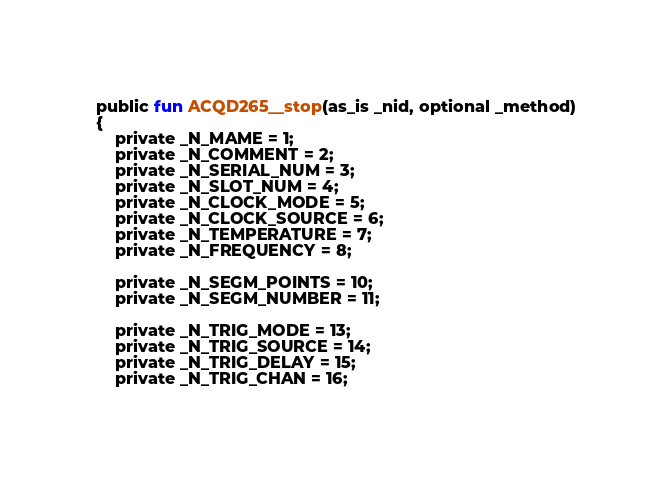Convert code to text. <code><loc_0><loc_0><loc_500><loc_500><_SML_>public fun ACQD265__stop(as_is _nid, optional _method)
{
    private _N_MAME = 1;
    private _N_COMMENT = 2;
    private _N_SERIAL_NUM = 3;
    private _N_SLOT_NUM = 4;
    private _N_CLOCK_MODE = 5;
    private _N_CLOCK_SOURCE = 6;
    private _N_TEMPERATURE = 7;
    private _N_FREQUENCY = 8;

    private _N_SEGM_POINTS = 10;
    private _N_SEGM_NUMBER = 11;

    private _N_TRIG_MODE = 13;
    private _N_TRIG_SOURCE = 14;
    private _N_TRIG_DELAY = 15;
    private _N_TRIG_CHAN = 16;</code> 